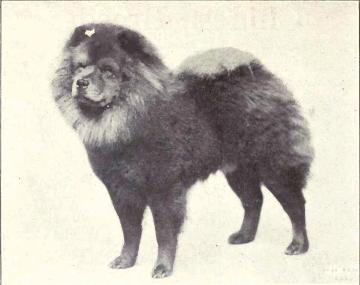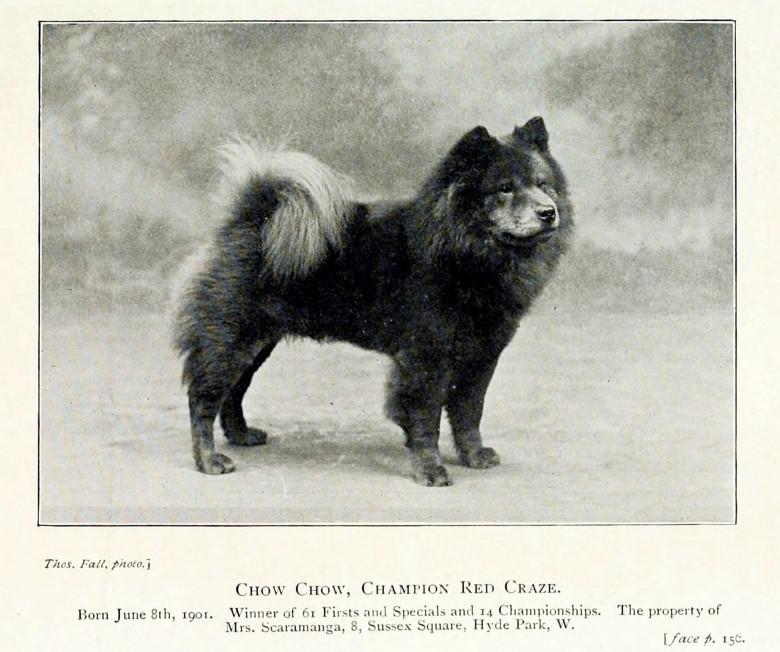The first image is the image on the left, the second image is the image on the right. Considering the images on both sides, is "Each image contains one solid black dog, and all dogs have their bodies turned rightward." valid? Answer yes or no. No. The first image is the image on the left, the second image is the image on the right. Assess this claim about the two images: "The dog in one of the images is lying down.". Correct or not? Answer yes or no. No. 